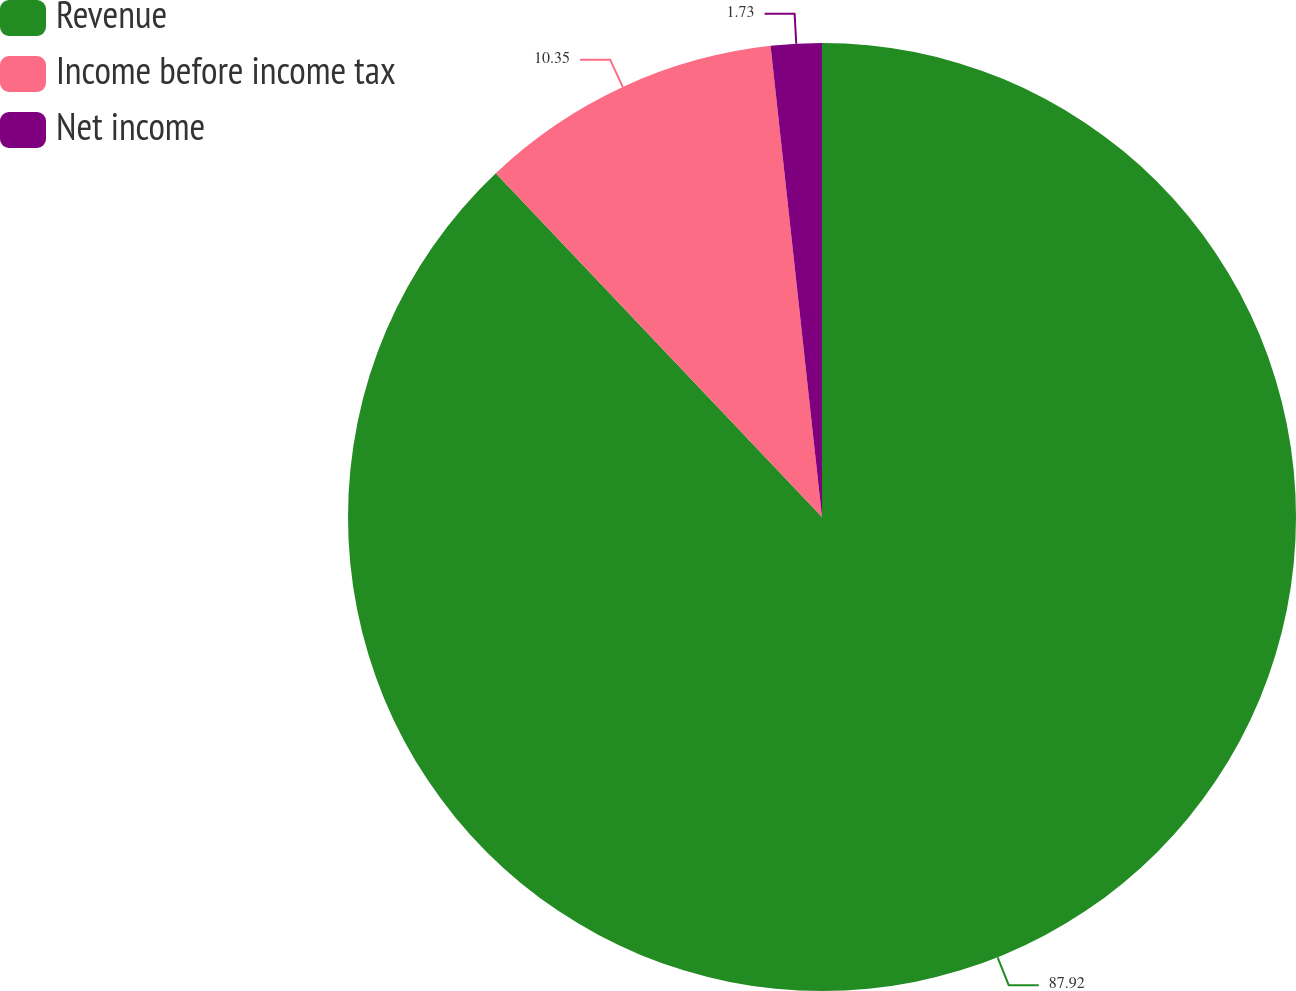Convert chart. <chart><loc_0><loc_0><loc_500><loc_500><pie_chart><fcel>Revenue<fcel>Income before income tax<fcel>Net income<nl><fcel>87.91%<fcel>10.35%<fcel>1.73%<nl></chart> 